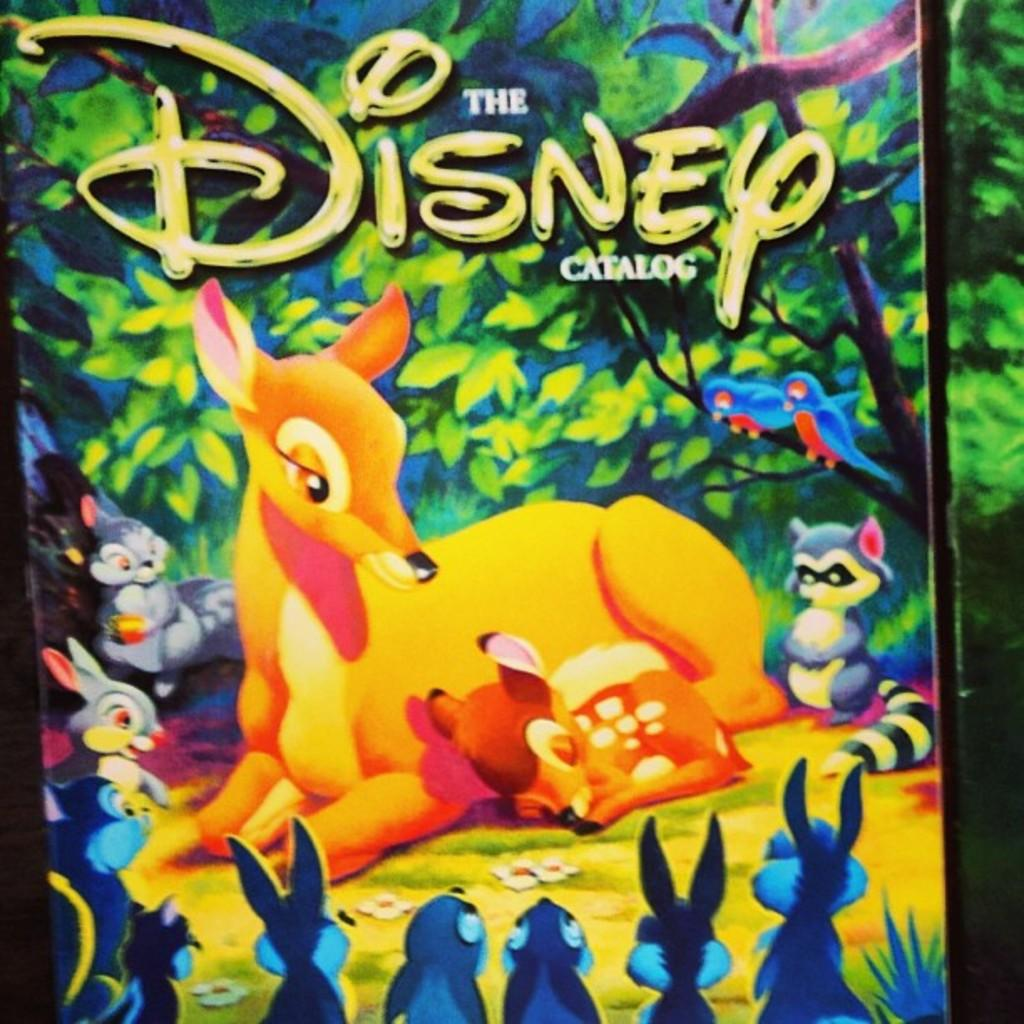What is the main subject of the image? There is a photo in the image. What can be seen in the photo? The photo contains animals. Is there any text visible on the photo? Yes, the word "DISNEY" is visible on the photo. What type of list can be seen in the image? There is no list present in the image; it features a photo with animals and the word "DISNEY." 